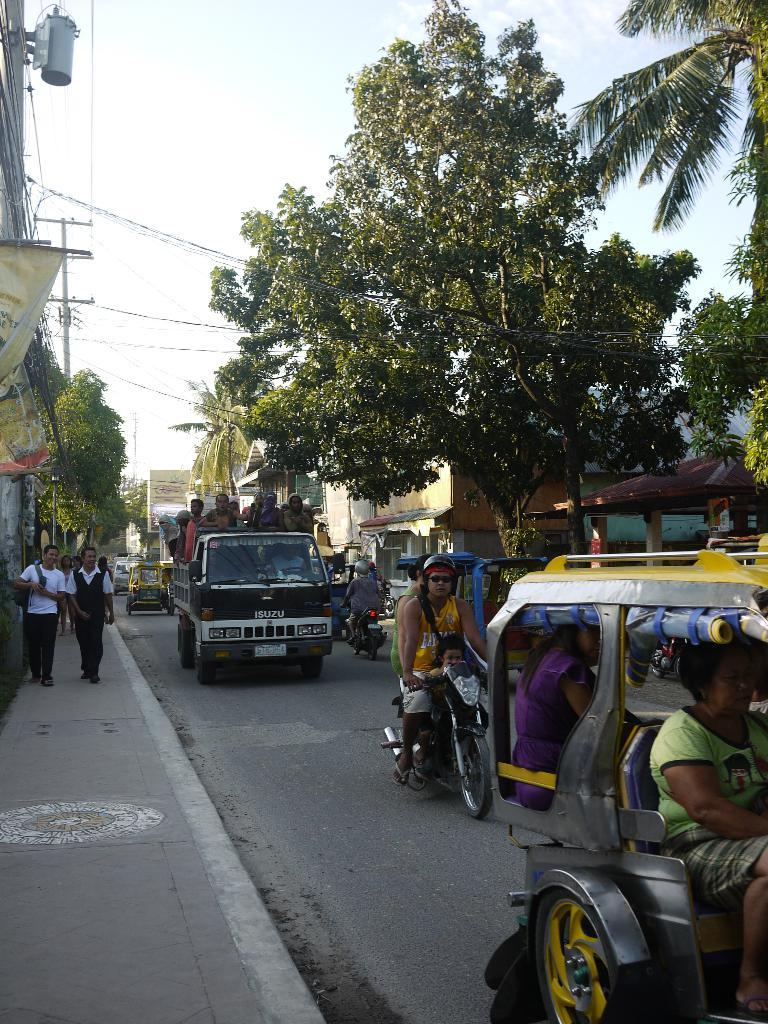What is happening in the foreground of the image? There are vehicles moving on the road and people walking on the side path in the foreground. What can be seen in the background of the image? There are houses, trees, cables, and the sky visible in the background. Where is the grandmother pointing in the image? There is no grandmother present in the image, and therefore no pointing can be observed. What is the best way to reach the destination in the image? The image does not provide information about a specific destination or the best way to reach it. 